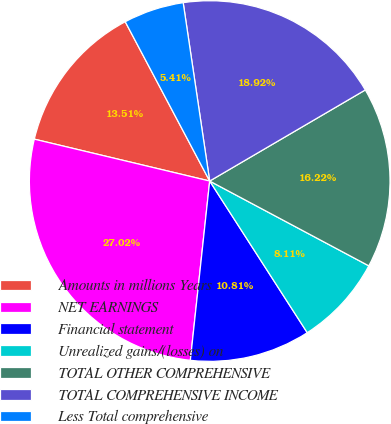Convert chart to OTSL. <chart><loc_0><loc_0><loc_500><loc_500><pie_chart><fcel>Amounts in millions Years<fcel>NET EARNINGS<fcel>Financial statement<fcel>Unrealized gains/(losses) on<fcel>TOTAL OTHER COMPREHENSIVE<fcel>TOTAL COMPREHENSIVE INCOME<fcel>Less Total comprehensive<nl><fcel>13.51%<fcel>27.02%<fcel>10.81%<fcel>8.11%<fcel>16.22%<fcel>18.92%<fcel>5.41%<nl></chart> 